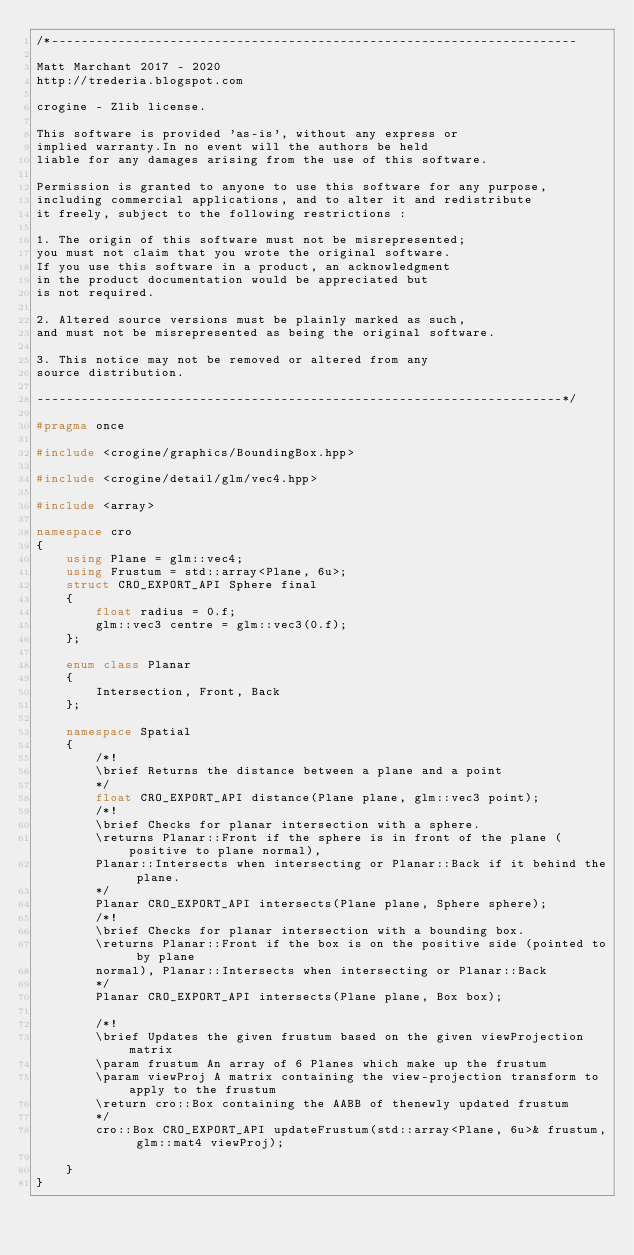<code> <loc_0><loc_0><loc_500><loc_500><_C++_>/*-----------------------------------------------------------------------

Matt Marchant 2017 - 2020
http://trederia.blogspot.com

crogine - Zlib license.

This software is provided 'as-is', without any express or
implied warranty.In no event will the authors be held
liable for any damages arising from the use of this software.

Permission is granted to anyone to use this software for any purpose,
including commercial applications, and to alter it and redistribute
it freely, subject to the following restrictions :

1. The origin of this software must not be misrepresented;
you must not claim that you wrote the original software.
If you use this software in a product, an acknowledgment
in the product documentation would be appreciated but
is not required.

2. Altered source versions must be plainly marked as such,
and must not be misrepresented as being the original software.

3. This notice may not be removed or altered from any
source distribution.

-----------------------------------------------------------------------*/

#pragma once

#include <crogine/graphics/BoundingBox.hpp>

#include <crogine/detail/glm/vec4.hpp>

#include <array>

namespace cro
{
    using Plane = glm::vec4;
    using Frustum = std::array<Plane, 6u>;
    struct CRO_EXPORT_API Sphere final
    {
        float radius = 0.f;
        glm::vec3 centre = glm::vec3(0.f);
    };

    enum class Planar
    {
        Intersection, Front, Back
    };

    namespace Spatial
    {
        /*!
        \brief Returns the distance between a plane and a point
        */
        float CRO_EXPORT_API distance(Plane plane, glm::vec3 point);
        /*!
        \brief Checks for planar intersection with a sphere.
        \returns Planar::Front if the sphere is in front of the plane (positive to plane normal),
        Planar::Intersects when intersecting or Planar::Back if it behind the plane.
        */
        Planar CRO_EXPORT_API intersects(Plane plane, Sphere sphere);
        /*!
        \brief Checks for planar intersection with a bounding box.
        \returns Planar::Front if the box is on the positive side (pointed to by plane
        normal), Planar::Intersects when intersecting or Planar::Back
        */
        Planar CRO_EXPORT_API intersects(Plane plane, Box box);

        /*!
        \brief Updates the given frustum based on the given viewProjection matrix
        \param frustum An array of 6 Planes which make up the frustum
        \param viewProj A matrix containing the view-projection transform to apply to the frustum
        \return cro::Box containing the AABB of thenewly updated frustum
        */
        cro::Box CRO_EXPORT_API updateFrustum(std::array<Plane, 6u>& frustum, glm::mat4 viewProj);

    }
}</code> 